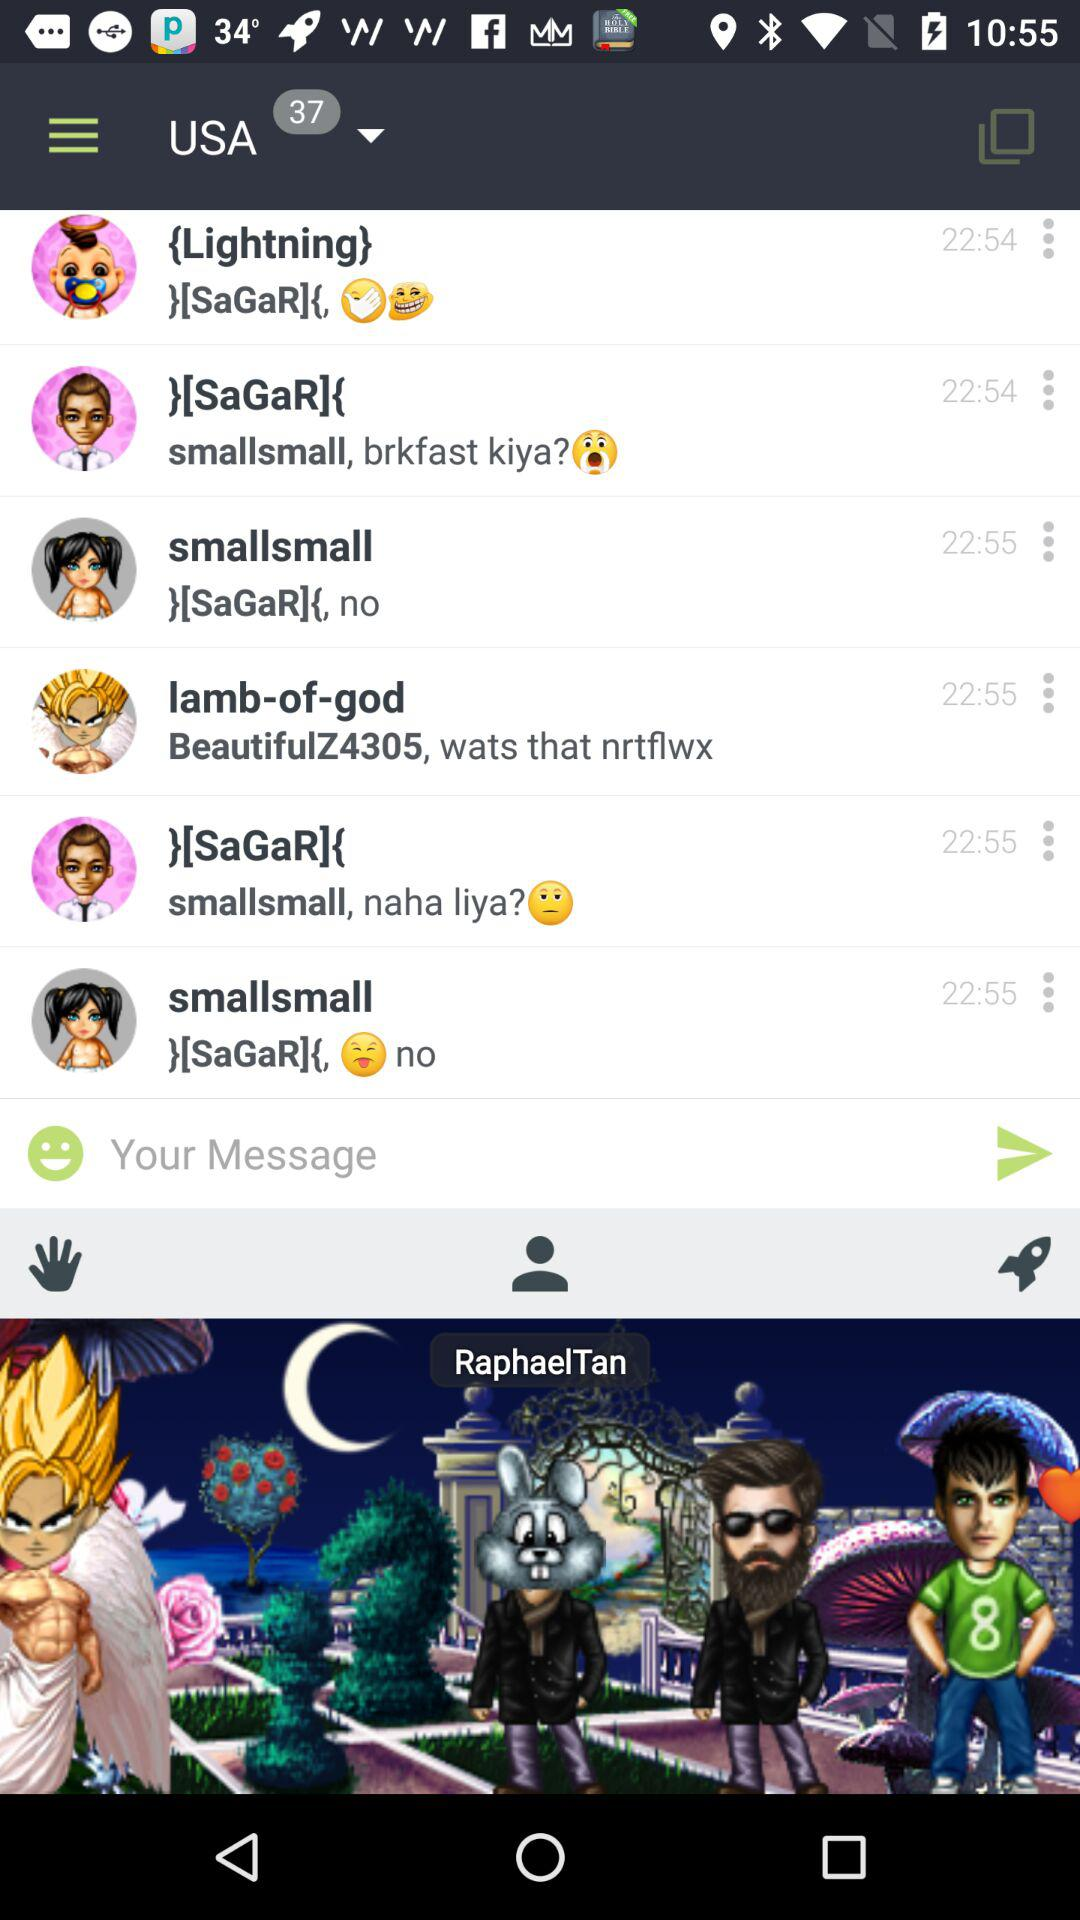What is the user name? The user name is "RaphaelTan". 